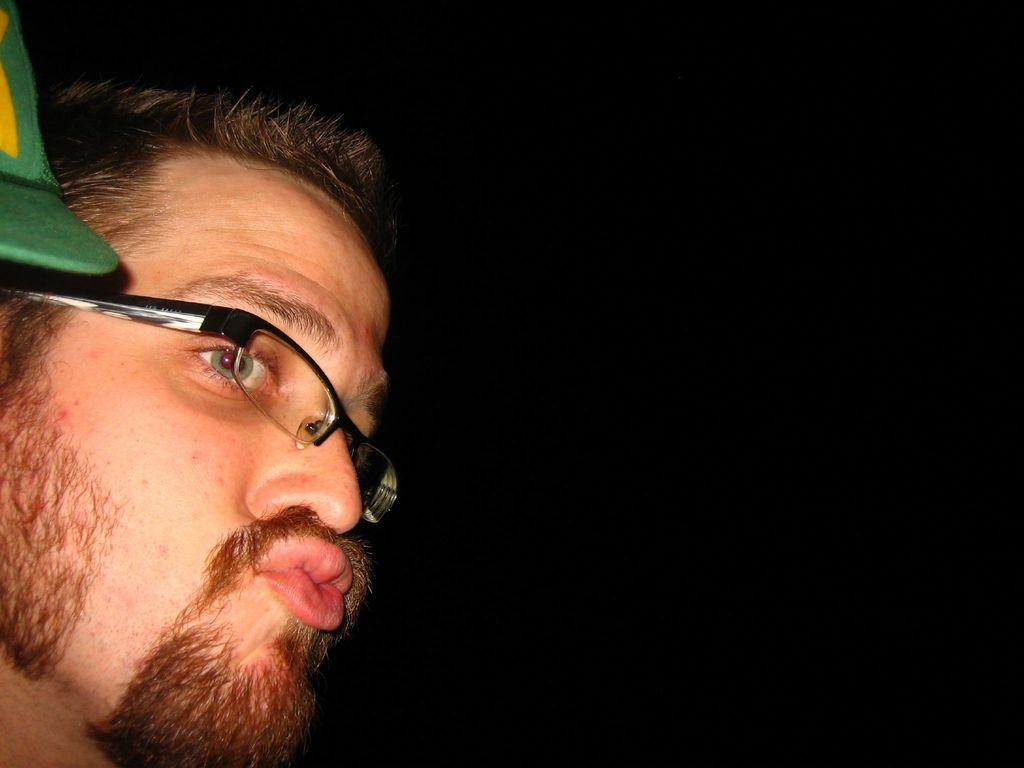What is present in the image? There is a man in the image. Can you describe the man's appearance? The man is wearing glasses. What type of hat is the man wearing in the image? There is no hat present in the image; the man is only wearing glasses. How does the man use friction to his advantage in the image? The image does not depict any actions or situations that involve friction, so it cannot be determined how the man might use friction. 